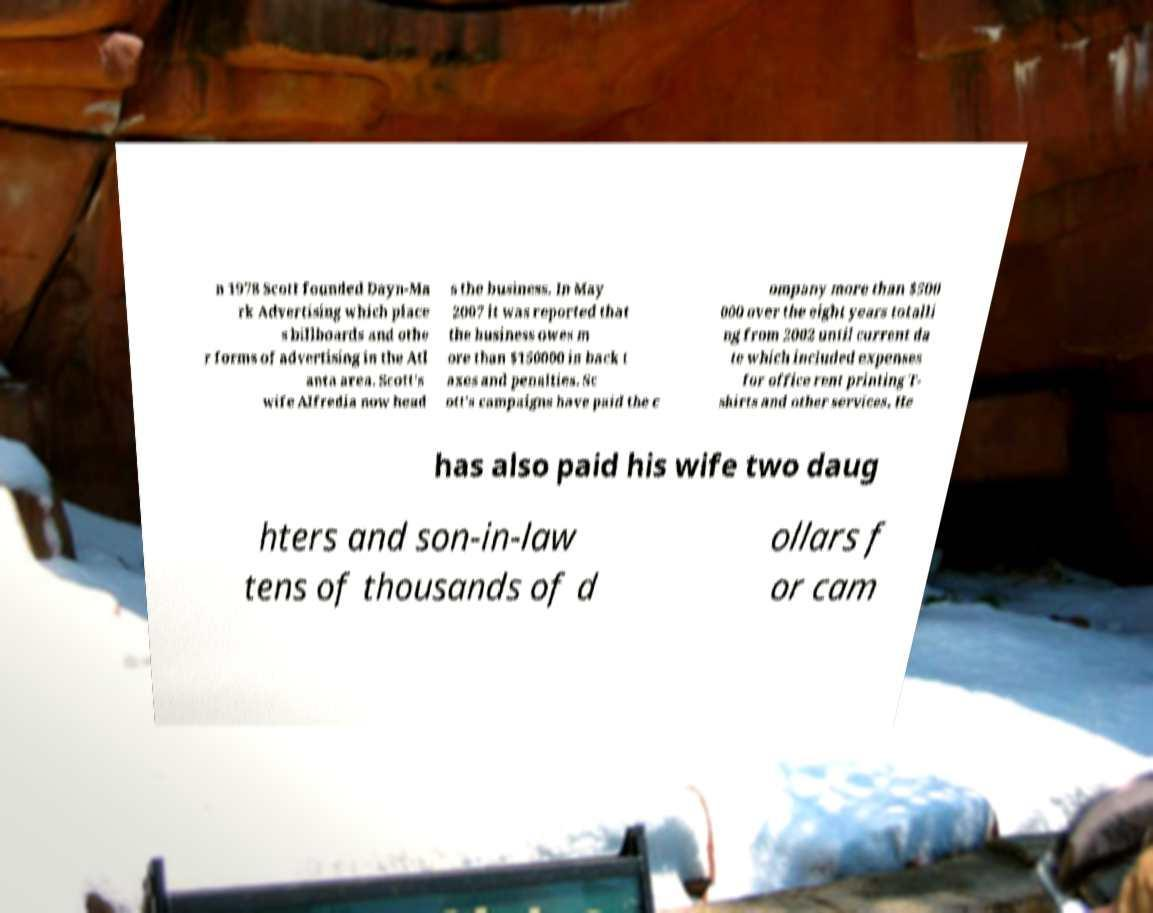Please read and relay the text visible in this image. What does it say? n 1978 Scott founded Dayn-Ma rk Advertising which place s billboards and othe r forms of advertising in the Atl anta area. Scott's wife Alfredia now head s the business. In May 2007 it was reported that the business owes m ore than $150000 in back t axes and penalties. Sc ott's campaigns have paid the c ompany more than $500 000 over the eight years totalli ng from 2002 until current da te which included expenses for office rent printing T- shirts and other services. He has also paid his wife two daug hters and son-in-law tens of thousands of d ollars f or cam 